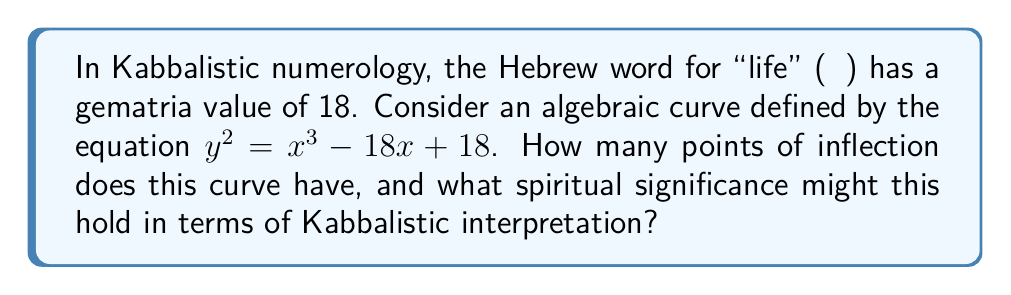Give your solution to this math problem. Let's approach this step-by-step:

1) First, we need to determine if this curve is an elliptic curve. The general form of an elliptic curve is $y^2 = x^3 + ax + b$. Our curve fits this form with $a = -18$ and $b = 18$.

2) For an elliptic curve, the number of points of inflection is always 3 in the complex plane, and they lie on a straight line.

3) To find the points of inflection, we need to calculate the second derivative of $y$ with respect to $x$ and set it equal to zero:

   $$\frac{d^2y}{dx^2} = \frac{d}{dx}\left(\frac{dy}{dx}\right) = \frac{d}{dx}\left(\frac{3x^2 - 18}{2y}\right) = 0$$

4) Solving this equation gives us the x-coordinates of the points of inflection.

5) In Kabbalistic numerology, the number 3 is significant. It represents the three pillars of the Tree of Life: Severity, Mercy, and Equilibrium.

6) The fact that our curve, derived from the gematria value of "life" (18), has 3 points of inflection could be interpreted as a connection between life and the fundamental structure of the Kabbalistic universe.

7) Moreover, in Kabbalah, the number 18 is associated with "chai" (life), and the fact that it appears twice in our equation ($-18x$ and $+18$) could be seen as emphasizing the cyclical nature of life and death in Kabbalistic thought.
Answer: 3 points of inflection, symbolizing the three pillars of the Kabbalistic Tree of Life. 